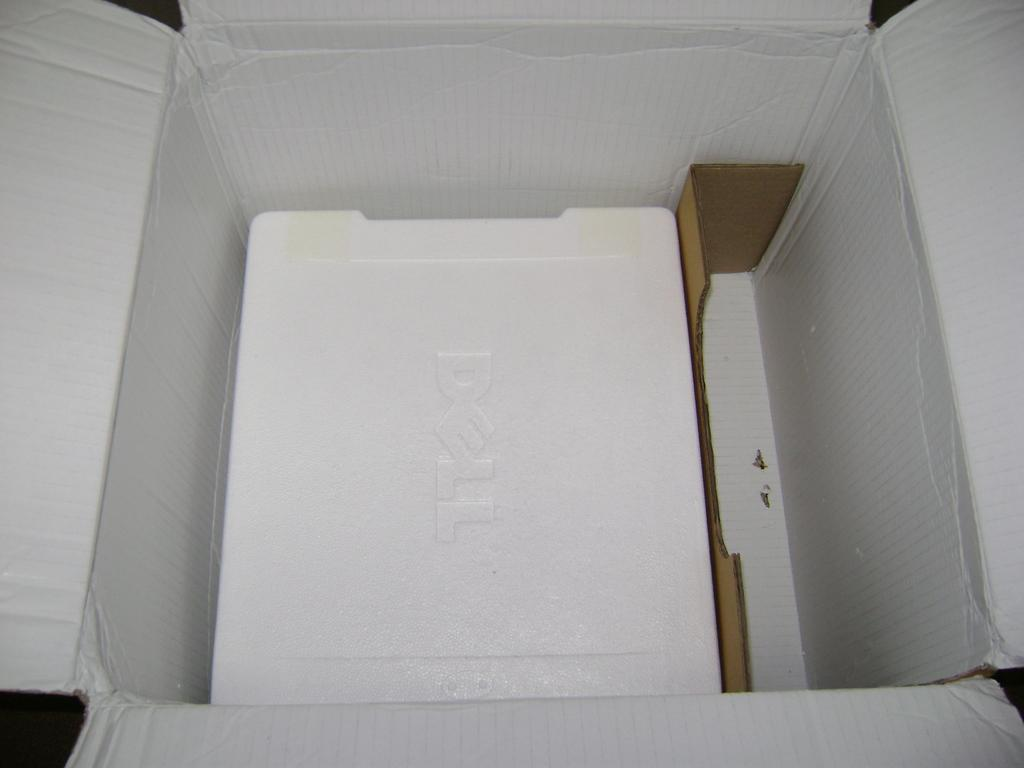Provide a one-sentence caption for the provided image. An open box with styrofoam covering a Dell compter. 